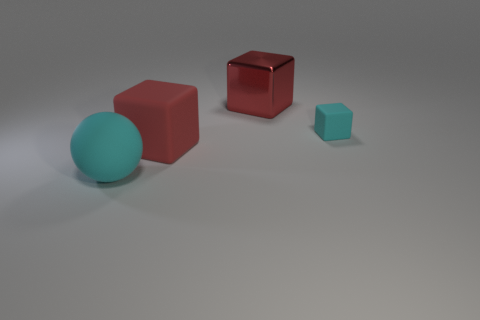What size is the cyan matte thing on the right side of the cyan rubber object that is to the left of the cyan block?
Make the answer very short. Small. There is a cube that is in front of the metallic object and left of the small cyan object; what material is it made of?
Offer a terse response. Rubber. What number of other objects are the same size as the shiny thing?
Keep it short and to the point. 2. What is the color of the metallic object?
Make the answer very short. Red. There is a big cube behind the small thing; is it the same color as the cube that is in front of the tiny object?
Offer a terse response. Yes. The cyan sphere is what size?
Provide a succinct answer. Large. What is the size of the rubber cube to the left of the red metal object?
Offer a very short reply. Large. There is a large thing that is both right of the matte sphere and in front of the big red shiny cube; what is its shape?
Provide a short and direct response. Cube. What number of other objects are there of the same shape as the red matte thing?
Provide a short and direct response. 2. There is a rubber sphere that is the same size as the metallic thing; what is its color?
Give a very brief answer. Cyan. 